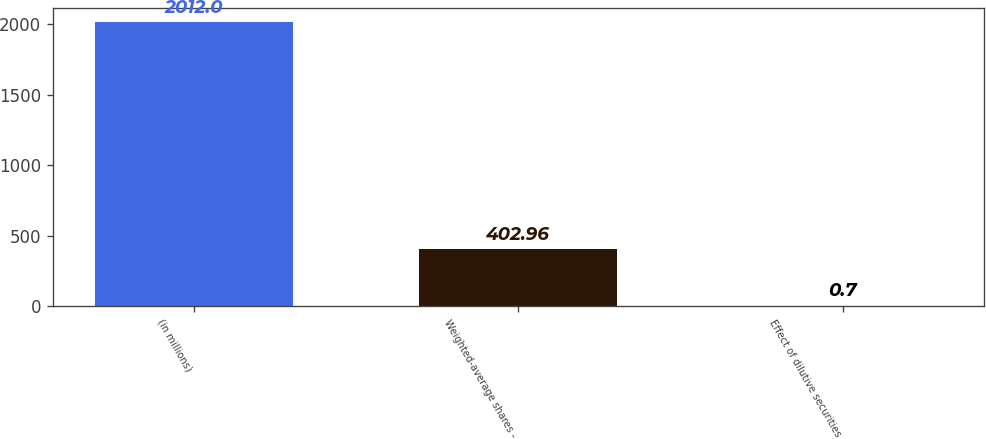Convert chart. <chart><loc_0><loc_0><loc_500><loc_500><bar_chart><fcel>(in millions)<fcel>Weighted-average shares -<fcel>Effect of dilutive securities<nl><fcel>2012<fcel>402.96<fcel>0.7<nl></chart> 